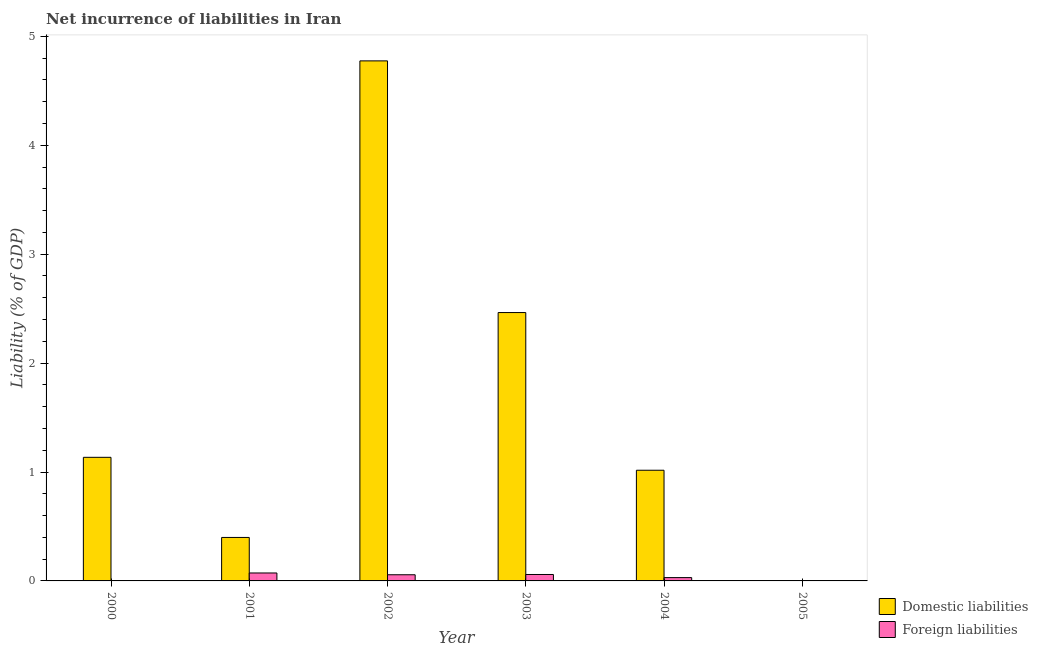How many bars are there on the 4th tick from the left?
Offer a very short reply. 2. In how many cases, is the number of bars for a given year not equal to the number of legend labels?
Offer a terse response. 2. What is the incurrence of domestic liabilities in 2000?
Offer a terse response. 1.13. Across all years, what is the maximum incurrence of foreign liabilities?
Your response must be concise. 0.07. In which year was the incurrence of domestic liabilities maximum?
Make the answer very short. 2002. What is the total incurrence of foreign liabilities in the graph?
Your answer should be compact. 0.22. What is the difference between the incurrence of domestic liabilities in 2002 and that in 2003?
Make the answer very short. 2.31. What is the difference between the incurrence of foreign liabilities in 2001 and the incurrence of domestic liabilities in 2003?
Make the answer very short. 0.01. What is the average incurrence of domestic liabilities per year?
Give a very brief answer. 1.63. In the year 2003, what is the difference between the incurrence of foreign liabilities and incurrence of domestic liabilities?
Your answer should be very brief. 0. What is the ratio of the incurrence of domestic liabilities in 2001 to that in 2004?
Your response must be concise. 0.39. Is the incurrence of foreign liabilities in 2001 less than that in 2003?
Your response must be concise. No. What is the difference between the highest and the second highest incurrence of foreign liabilities?
Ensure brevity in your answer.  0.01. What is the difference between the highest and the lowest incurrence of foreign liabilities?
Offer a terse response. 0.07. How many bars are there?
Offer a terse response. 9. Are all the bars in the graph horizontal?
Provide a short and direct response. No. How many years are there in the graph?
Your response must be concise. 6. What is the difference between two consecutive major ticks on the Y-axis?
Your response must be concise. 1. Are the values on the major ticks of Y-axis written in scientific E-notation?
Your response must be concise. No. Does the graph contain any zero values?
Give a very brief answer. Yes. How many legend labels are there?
Keep it short and to the point. 2. What is the title of the graph?
Your response must be concise. Net incurrence of liabilities in Iran. Does "Register a property" appear as one of the legend labels in the graph?
Your response must be concise. No. What is the label or title of the X-axis?
Your response must be concise. Year. What is the label or title of the Y-axis?
Offer a very short reply. Liability (% of GDP). What is the Liability (% of GDP) in Domestic liabilities in 2000?
Provide a short and direct response. 1.13. What is the Liability (% of GDP) in Domestic liabilities in 2001?
Provide a succinct answer. 0.4. What is the Liability (% of GDP) of Foreign liabilities in 2001?
Provide a succinct answer. 0.07. What is the Liability (% of GDP) in Domestic liabilities in 2002?
Offer a very short reply. 4.78. What is the Liability (% of GDP) of Foreign liabilities in 2002?
Keep it short and to the point. 0.06. What is the Liability (% of GDP) of Domestic liabilities in 2003?
Make the answer very short. 2.46. What is the Liability (% of GDP) in Foreign liabilities in 2003?
Your answer should be compact. 0.06. What is the Liability (% of GDP) in Domestic liabilities in 2004?
Ensure brevity in your answer.  1.02. What is the Liability (% of GDP) in Foreign liabilities in 2004?
Your answer should be compact. 0.03. What is the Liability (% of GDP) of Domestic liabilities in 2005?
Provide a succinct answer. 0. Across all years, what is the maximum Liability (% of GDP) of Domestic liabilities?
Make the answer very short. 4.78. Across all years, what is the maximum Liability (% of GDP) of Foreign liabilities?
Your response must be concise. 0.07. Across all years, what is the minimum Liability (% of GDP) in Domestic liabilities?
Your response must be concise. 0. Across all years, what is the minimum Liability (% of GDP) in Foreign liabilities?
Your response must be concise. 0. What is the total Liability (% of GDP) of Domestic liabilities in the graph?
Offer a very short reply. 9.79. What is the total Liability (% of GDP) of Foreign liabilities in the graph?
Provide a short and direct response. 0.22. What is the difference between the Liability (% of GDP) in Domestic liabilities in 2000 and that in 2001?
Offer a terse response. 0.74. What is the difference between the Liability (% of GDP) of Domestic liabilities in 2000 and that in 2002?
Your answer should be compact. -3.64. What is the difference between the Liability (% of GDP) in Domestic liabilities in 2000 and that in 2003?
Offer a very short reply. -1.33. What is the difference between the Liability (% of GDP) in Domestic liabilities in 2000 and that in 2004?
Your response must be concise. 0.12. What is the difference between the Liability (% of GDP) of Domestic liabilities in 2001 and that in 2002?
Offer a terse response. -4.38. What is the difference between the Liability (% of GDP) in Foreign liabilities in 2001 and that in 2002?
Ensure brevity in your answer.  0.02. What is the difference between the Liability (% of GDP) in Domestic liabilities in 2001 and that in 2003?
Give a very brief answer. -2.06. What is the difference between the Liability (% of GDP) of Foreign liabilities in 2001 and that in 2003?
Provide a short and direct response. 0.01. What is the difference between the Liability (% of GDP) in Domestic liabilities in 2001 and that in 2004?
Your answer should be compact. -0.62. What is the difference between the Liability (% of GDP) of Foreign liabilities in 2001 and that in 2004?
Make the answer very short. 0.04. What is the difference between the Liability (% of GDP) in Domestic liabilities in 2002 and that in 2003?
Keep it short and to the point. 2.31. What is the difference between the Liability (% of GDP) of Foreign liabilities in 2002 and that in 2003?
Ensure brevity in your answer.  -0. What is the difference between the Liability (% of GDP) in Domestic liabilities in 2002 and that in 2004?
Your response must be concise. 3.76. What is the difference between the Liability (% of GDP) in Foreign liabilities in 2002 and that in 2004?
Make the answer very short. 0.03. What is the difference between the Liability (% of GDP) in Domestic liabilities in 2003 and that in 2004?
Offer a terse response. 1.45. What is the difference between the Liability (% of GDP) in Foreign liabilities in 2003 and that in 2004?
Provide a short and direct response. 0.03. What is the difference between the Liability (% of GDP) in Domestic liabilities in 2000 and the Liability (% of GDP) in Foreign liabilities in 2001?
Offer a very short reply. 1.06. What is the difference between the Liability (% of GDP) in Domestic liabilities in 2000 and the Liability (% of GDP) in Foreign liabilities in 2002?
Offer a terse response. 1.08. What is the difference between the Liability (% of GDP) in Domestic liabilities in 2000 and the Liability (% of GDP) in Foreign liabilities in 2003?
Your answer should be very brief. 1.08. What is the difference between the Liability (% of GDP) in Domestic liabilities in 2000 and the Liability (% of GDP) in Foreign liabilities in 2004?
Your answer should be very brief. 1.1. What is the difference between the Liability (% of GDP) in Domestic liabilities in 2001 and the Liability (% of GDP) in Foreign liabilities in 2002?
Provide a succinct answer. 0.34. What is the difference between the Liability (% of GDP) of Domestic liabilities in 2001 and the Liability (% of GDP) of Foreign liabilities in 2003?
Your answer should be very brief. 0.34. What is the difference between the Liability (% of GDP) of Domestic liabilities in 2001 and the Liability (% of GDP) of Foreign liabilities in 2004?
Offer a very short reply. 0.37. What is the difference between the Liability (% of GDP) of Domestic liabilities in 2002 and the Liability (% of GDP) of Foreign liabilities in 2003?
Your response must be concise. 4.72. What is the difference between the Liability (% of GDP) in Domestic liabilities in 2002 and the Liability (% of GDP) in Foreign liabilities in 2004?
Offer a terse response. 4.74. What is the difference between the Liability (% of GDP) of Domestic liabilities in 2003 and the Liability (% of GDP) of Foreign liabilities in 2004?
Offer a very short reply. 2.43. What is the average Liability (% of GDP) in Domestic liabilities per year?
Make the answer very short. 1.63. What is the average Liability (% of GDP) of Foreign liabilities per year?
Your answer should be compact. 0.04. In the year 2001, what is the difference between the Liability (% of GDP) of Domestic liabilities and Liability (% of GDP) of Foreign liabilities?
Your response must be concise. 0.33. In the year 2002, what is the difference between the Liability (% of GDP) in Domestic liabilities and Liability (% of GDP) in Foreign liabilities?
Offer a very short reply. 4.72. In the year 2003, what is the difference between the Liability (% of GDP) of Domestic liabilities and Liability (% of GDP) of Foreign liabilities?
Offer a very short reply. 2.41. In the year 2004, what is the difference between the Liability (% of GDP) in Domestic liabilities and Liability (% of GDP) in Foreign liabilities?
Provide a short and direct response. 0.99. What is the ratio of the Liability (% of GDP) of Domestic liabilities in 2000 to that in 2001?
Your answer should be very brief. 2.84. What is the ratio of the Liability (% of GDP) of Domestic liabilities in 2000 to that in 2002?
Offer a terse response. 0.24. What is the ratio of the Liability (% of GDP) in Domestic liabilities in 2000 to that in 2003?
Provide a short and direct response. 0.46. What is the ratio of the Liability (% of GDP) of Domestic liabilities in 2000 to that in 2004?
Provide a succinct answer. 1.12. What is the ratio of the Liability (% of GDP) in Domestic liabilities in 2001 to that in 2002?
Provide a short and direct response. 0.08. What is the ratio of the Liability (% of GDP) in Foreign liabilities in 2001 to that in 2002?
Keep it short and to the point. 1.29. What is the ratio of the Liability (% of GDP) in Domestic liabilities in 2001 to that in 2003?
Ensure brevity in your answer.  0.16. What is the ratio of the Liability (% of GDP) of Foreign liabilities in 2001 to that in 2003?
Offer a very short reply. 1.24. What is the ratio of the Liability (% of GDP) of Domestic liabilities in 2001 to that in 2004?
Provide a succinct answer. 0.39. What is the ratio of the Liability (% of GDP) of Foreign liabilities in 2001 to that in 2004?
Give a very brief answer. 2.39. What is the ratio of the Liability (% of GDP) of Domestic liabilities in 2002 to that in 2003?
Your response must be concise. 1.94. What is the ratio of the Liability (% of GDP) of Foreign liabilities in 2002 to that in 2003?
Make the answer very short. 0.96. What is the ratio of the Liability (% of GDP) of Domestic liabilities in 2002 to that in 2004?
Give a very brief answer. 4.7. What is the ratio of the Liability (% of GDP) of Foreign liabilities in 2002 to that in 2004?
Keep it short and to the point. 1.85. What is the ratio of the Liability (% of GDP) in Domestic liabilities in 2003 to that in 2004?
Your answer should be very brief. 2.42. What is the ratio of the Liability (% of GDP) in Foreign liabilities in 2003 to that in 2004?
Make the answer very short. 1.93. What is the difference between the highest and the second highest Liability (% of GDP) of Domestic liabilities?
Your response must be concise. 2.31. What is the difference between the highest and the second highest Liability (% of GDP) in Foreign liabilities?
Make the answer very short. 0.01. What is the difference between the highest and the lowest Liability (% of GDP) of Domestic liabilities?
Your answer should be very brief. 4.78. What is the difference between the highest and the lowest Liability (% of GDP) of Foreign liabilities?
Keep it short and to the point. 0.07. 